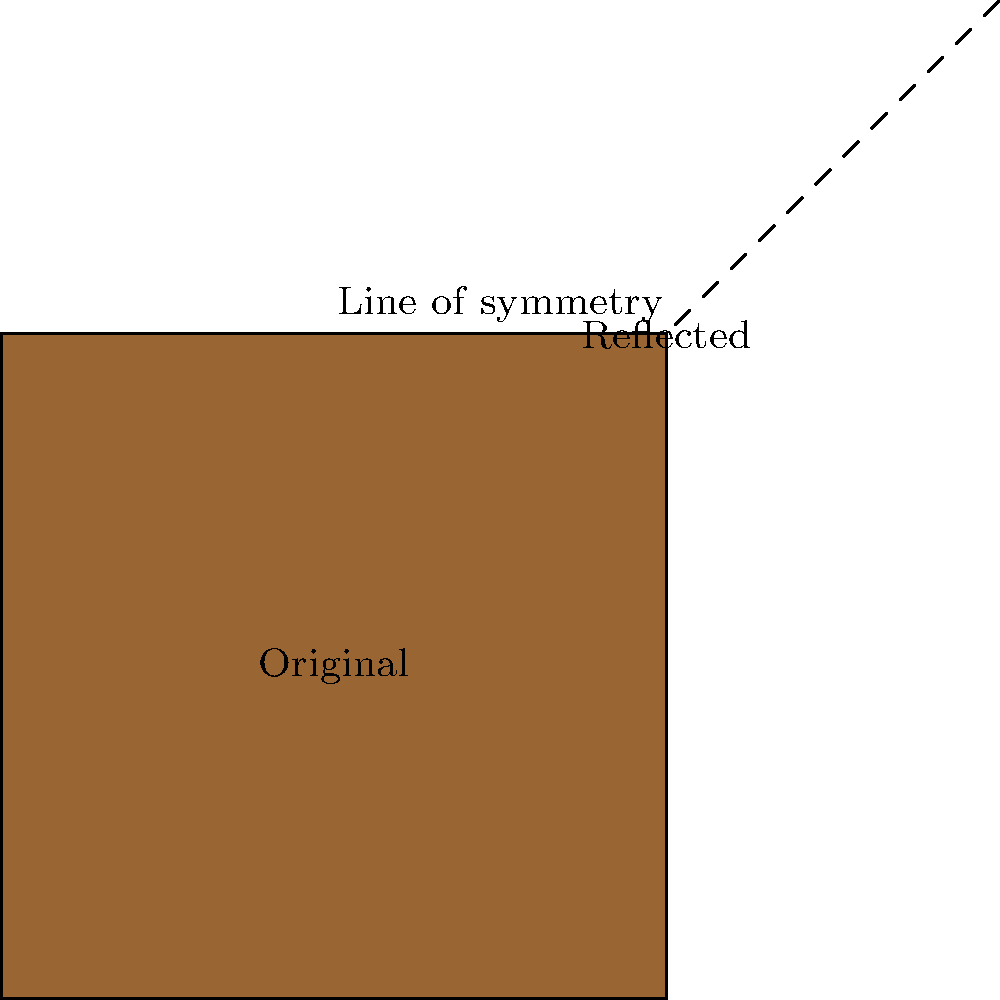In the context of album cover design, consider the reflection of a square album cover across a diagonal line of symmetry. If the original cover's top-right corner is at coordinates (4,4), what are the coordinates of the reflected cover's bottom-left corner? To solve this problem, we'll follow these steps:

1. Identify the line of symmetry: The diagonal line passing through (0,0) and (6,6) is our line of symmetry.

2. Understand the reflection: When reflecting across this line, points equidistant from the line will swap positions.

3. Locate the original corner: The top-right corner of the original cover is at (4,4).

4. Find the point's distance from the line of symmetry: 
   The point (4,4) is already on the line of symmetry, so its reflection will be itself.

5. Identify the opposite corner: The bottom-left corner of the reflected cover will be opposite to (4,4) in relation to the center of the square.

6. Calculate the center of the reflected square:
   The center will be at (4,4), as this point doesn't move during reflection.

7. Find the coordinates of the bottom-left corner:
   From the center (4,4), we need to go left 2 units and down 2 units.
   So, the coordinates will be (4-2, 4-2) = (2,2).

Therefore, the coordinates of the reflected cover's bottom-left corner are (2,2).
Answer: (2,2) 